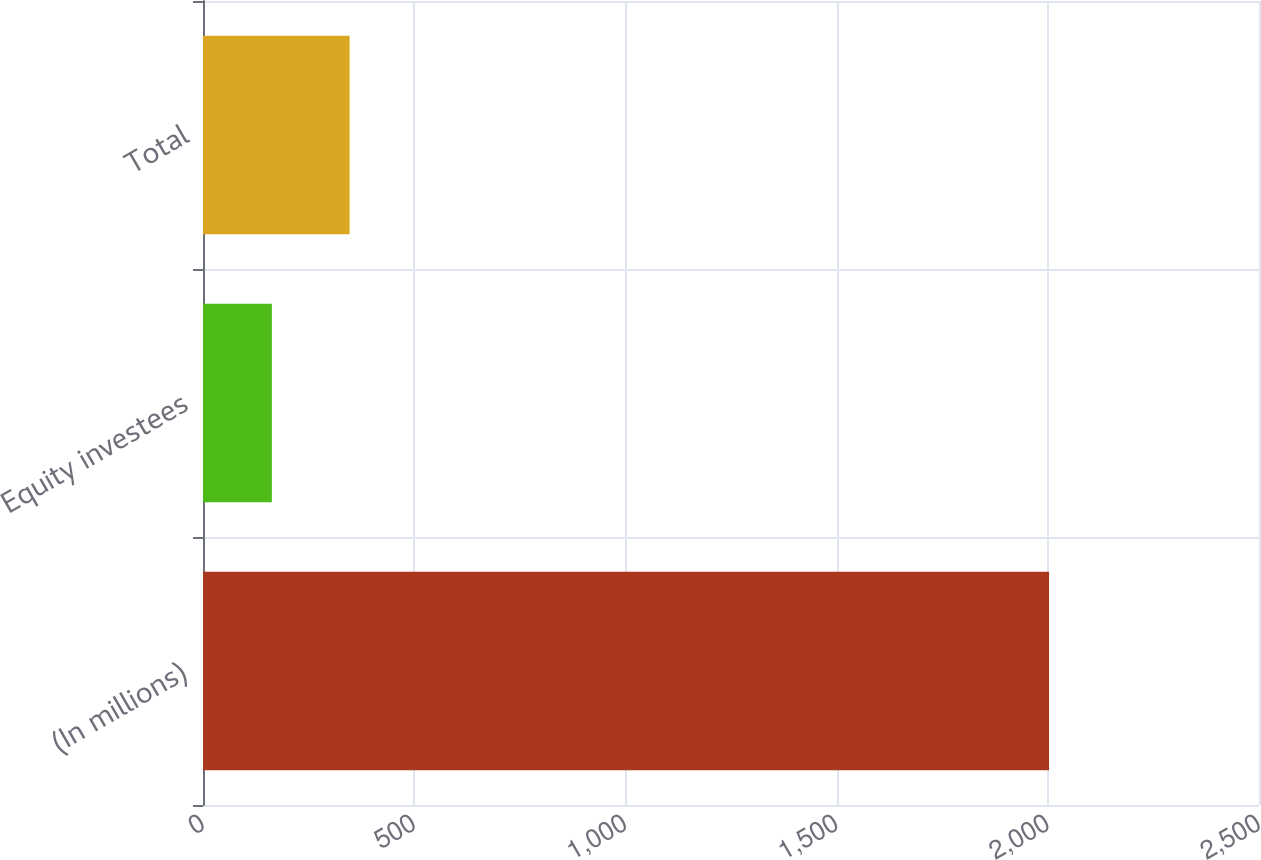<chart> <loc_0><loc_0><loc_500><loc_500><bar_chart><fcel>(In millions)<fcel>Equity investees<fcel>Total<nl><fcel>2003<fcel>163<fcel>347<nl></chart> 